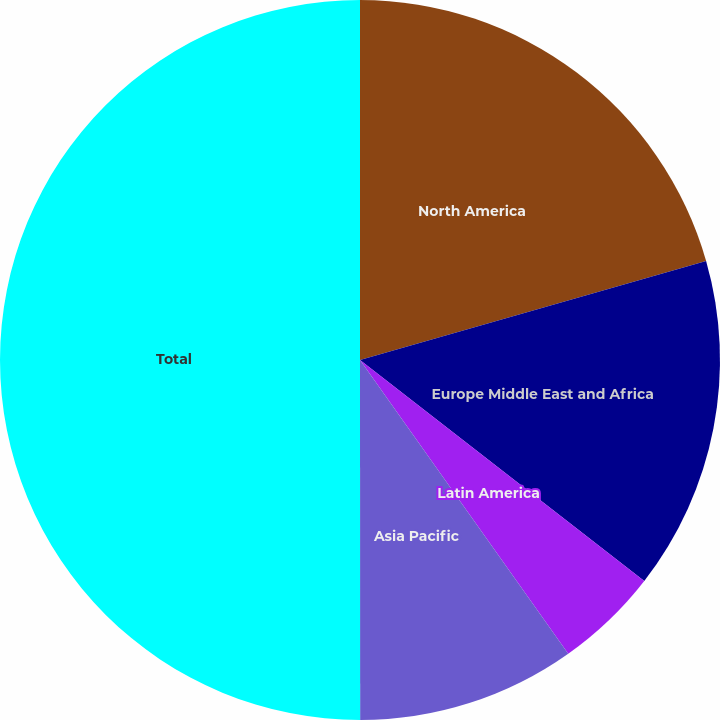Convert chart. <chart><loc_0><loc_0><loc_500><loc_500><pie_chart><fcel>North America<fcel>Europe Middle East and Africa<fcel>Latin America<fcel>Asia Pacific<fcel>Total<nl><fcel>20.56%<fcel>14.95%<fcel>4.67%<fcel>9.81%<fcel>50.0%<nl></chart> 